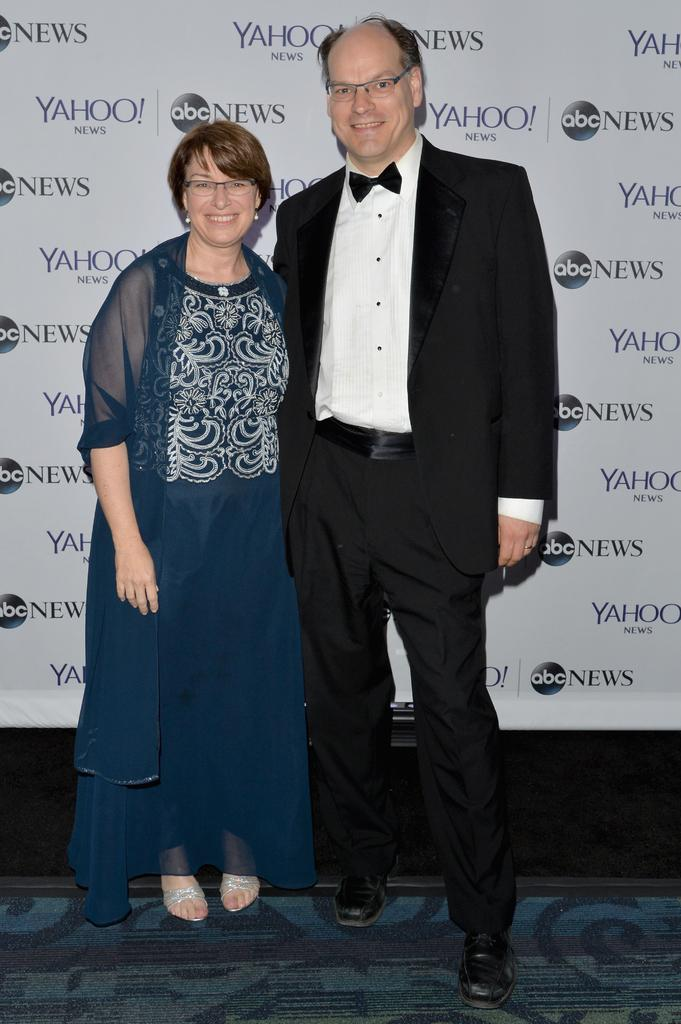How many people are in the image? There are two people in the image, a man and a woman. What are the man and the woman doing in the image? Both the man and the woman are standing and smiling. What is the man wearing in the image? The man is wearing a suit. What can be seen in the background of the image? There are logos visible in the background of the image. What is the rate of the observation in the image? There is no rate or observation present in the image; it simply features a man and a woman standing and smiling. What company is associated with the logos in the background? The provided facts do not mention any specific company associated with the logos in the background. 